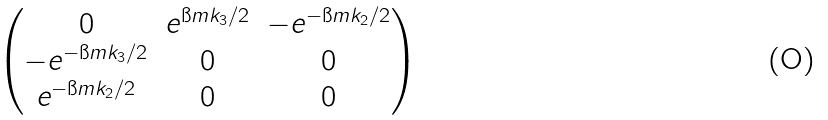Convert formula to latex. <formula><loc_0><loc_0><loc_500><loc_500>\begin{pmatrix} 0 & e ^ { \i m k _ { 3 } / 2 } & - e ^ { - \i m k _ { 2 } / 2 } \\ - e ^ { - \i m k _ { 3 } / 2 } & 0 & 0 \\ e ^ { - \i m k _ { 2 } / 2 } & 0 & 0 \end{pmatrix}</formula> 